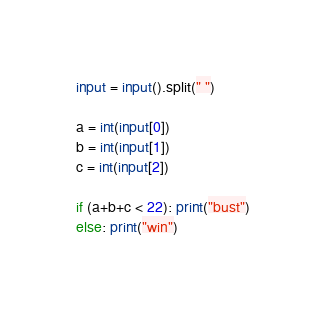<code> <loc_0><loc_0><loc_500><loc_500><_Python_>input = input().split(" ")

a = int(input[0])
b = int(input[1])
c = int(input[2])

if (a+b+c < 22): print("bust")
else: print("win")</code> 